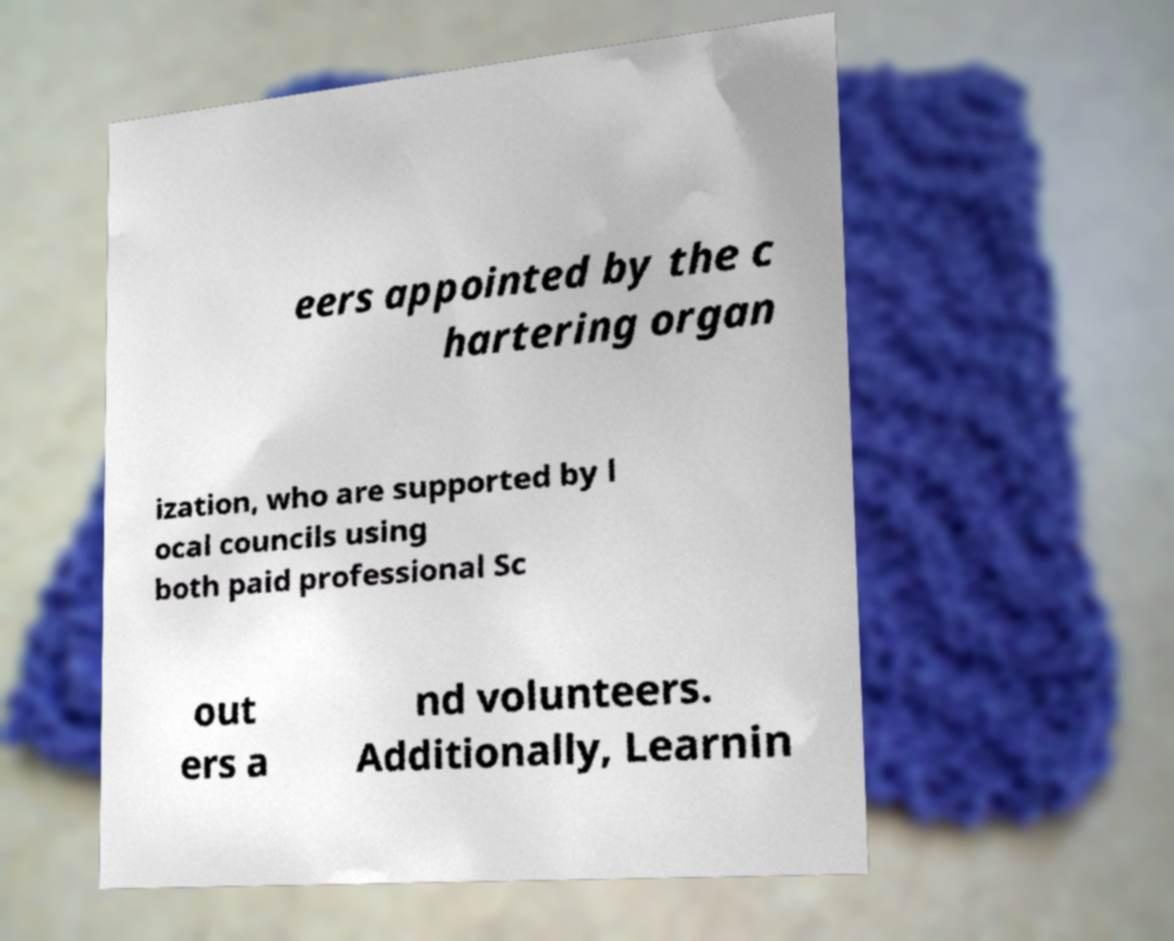Can you accurately transcribe the text from the provided image for me? eers appointed by the c hartering organ ization, who are supported by l ocal councils using both paid professional Sc out ers a nd volunteers. Additionally, Learnin 